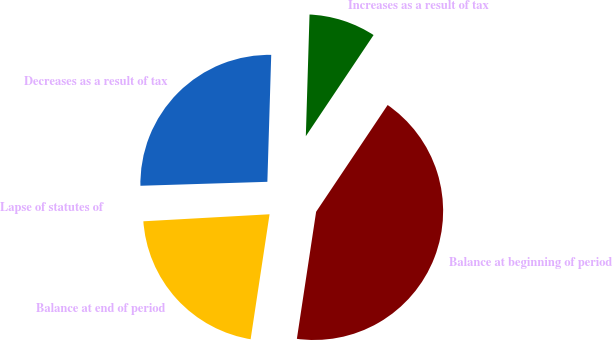<chart> <loc_0><loc_0><loc_500><loc_500><pie_chart><fcel>Balance at beginning of period<fcel>Increases as a result of tax<fcel>Decreases as a result of tax<fcel>Lapse of statutes of<fcel>Balance at end of period<nl><fcel>43.0%<fcel>8.91%<fcel>25.98%<fcel>0.39%<fcel>21.72%<nl></chart> 